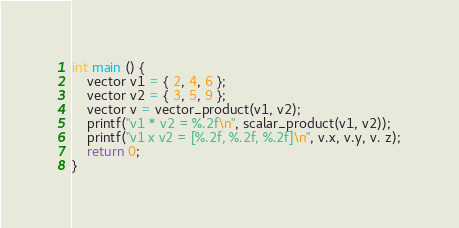Convert code to text. <code><loc_0><loc_0><loc_500><loc_500><_C_>

int main () {
    vector v1 = { 2, 4, 6 };
    vector v2 = { 3, 5, 9 };
    vector v = vector_product(v1, v2);
    printf("v1 * v2 = %.2f\n", scalar_product(v1, v2));
    printf("v1 x v2 = [%.2f, %.2f, %.2f]\n", v.x, v.y, v. z);
    return 0;
}
</code> 